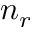<formula> <loc_0><loc_0><loc_500><loc_500>n _ { r }</formula> 